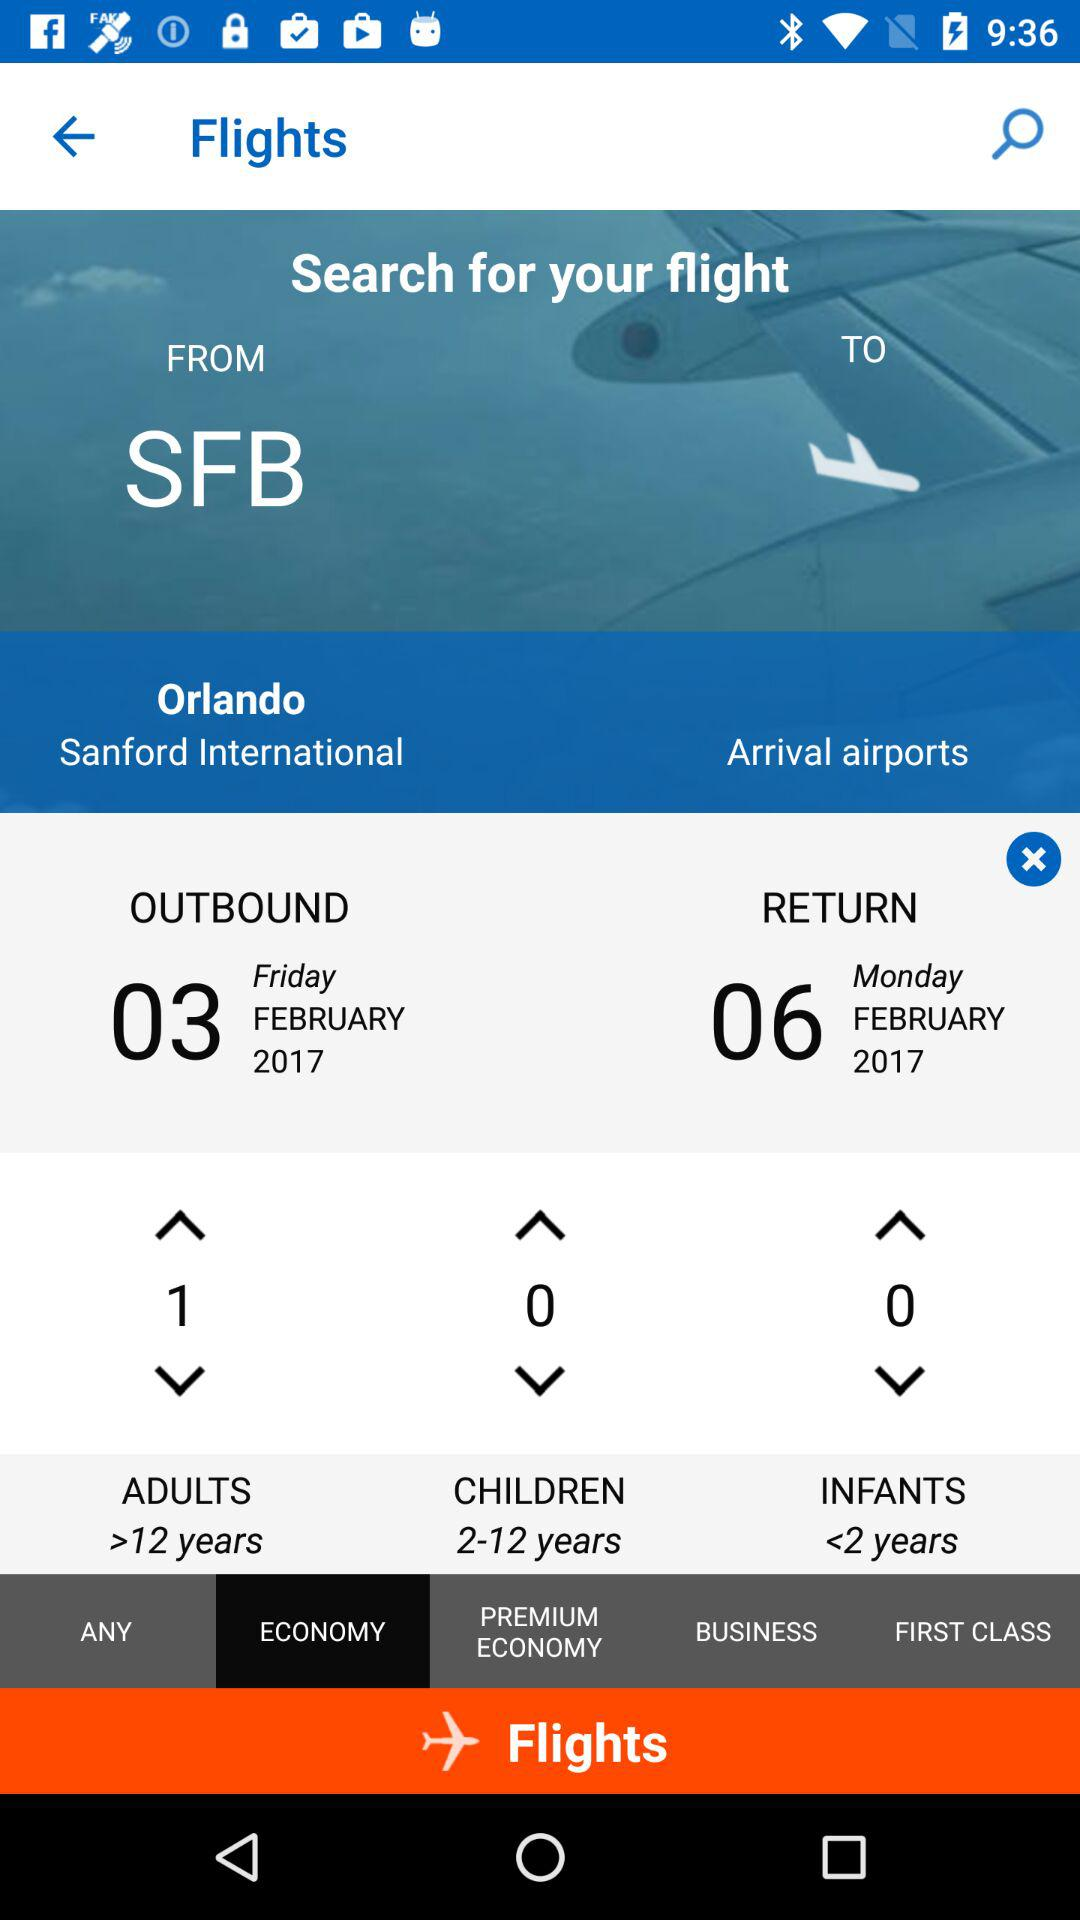How many adult passengers are there? There is 1 adult passenger. 